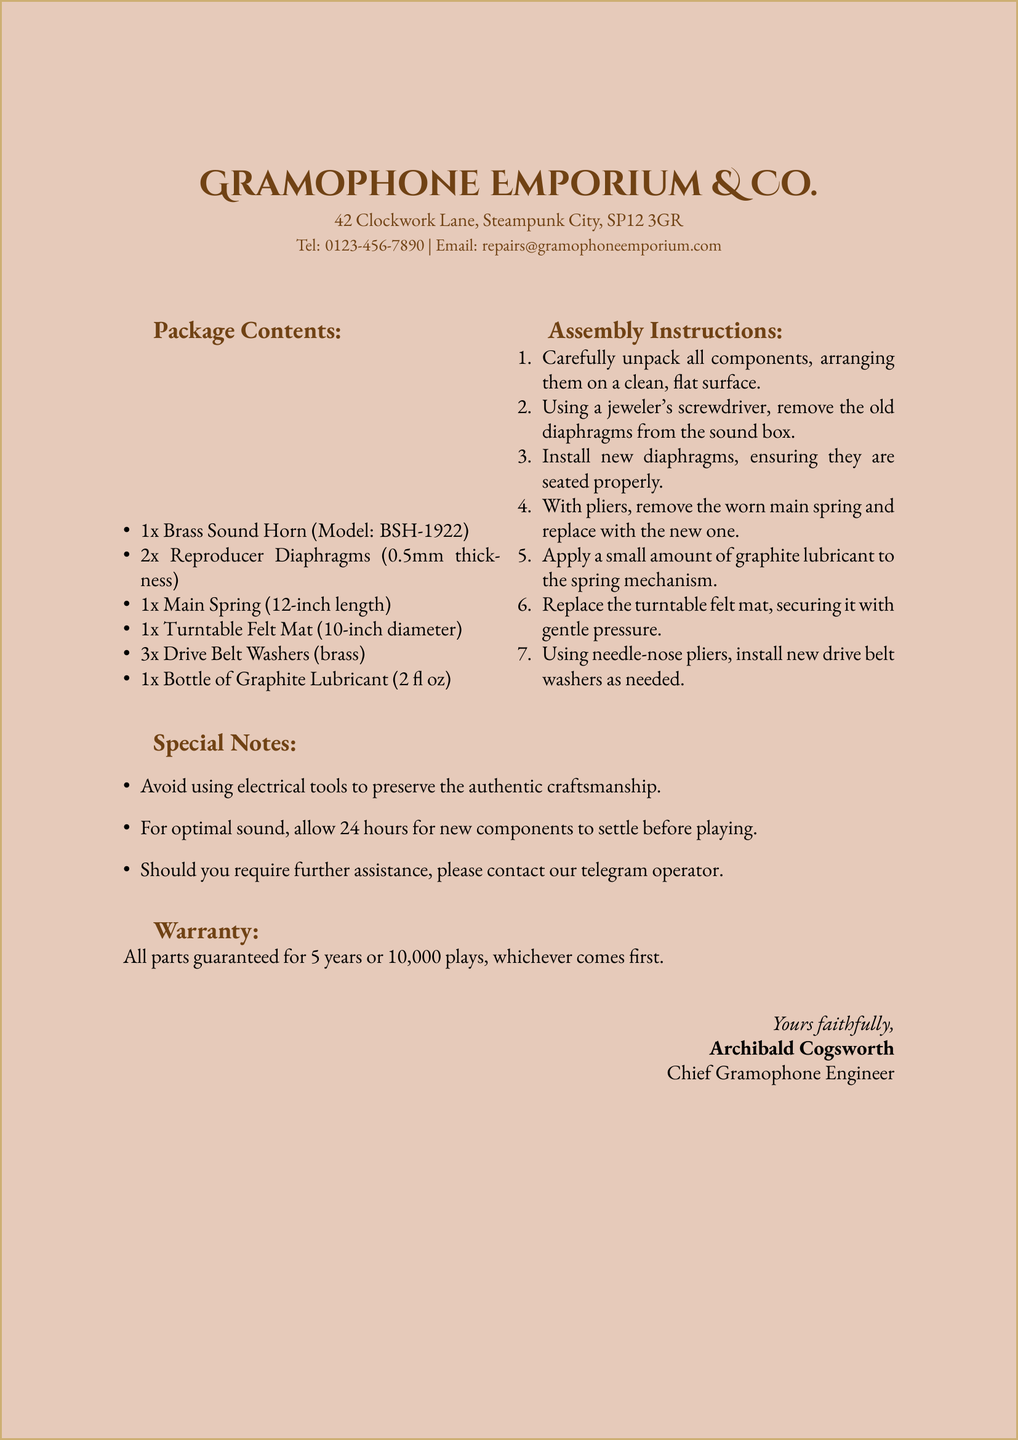What is the name of the company? The company name is stated in the header of the document.
Answer: Gramophone Emporium & Co What is the model of the brass sound horn? The model number is specified next to the item in the package contents.
Answer: BSH-1922 How many reproducer diaphragms are included? The quantity of each item is listed in the package contents.
Answer: 2x What tool is suggested for removing the old diaphragms? The assembly instructions specify the type of tool needed.
Answer: jeweler's screwdriver What should be applied to the spring mechanism? The assembly instructions indicate a specific lubricant to use.
Answer: graphite lubricant What is the warranty period for the parts? The warranty information is clearly stated at the end of the document.
Answer: 5 years What should be avoided to preserve craftsmanship? There is a note in the special notes section addressing this concern.
Answer: electrical tools How long should components settle before playing? The special notes provide guidance on the settling time.
Answer: 24 hours Who is the Chief Gramophone Engineer? The signature section reveals the name of the engineer in charge.
Answer: Archibald Cogsworth 